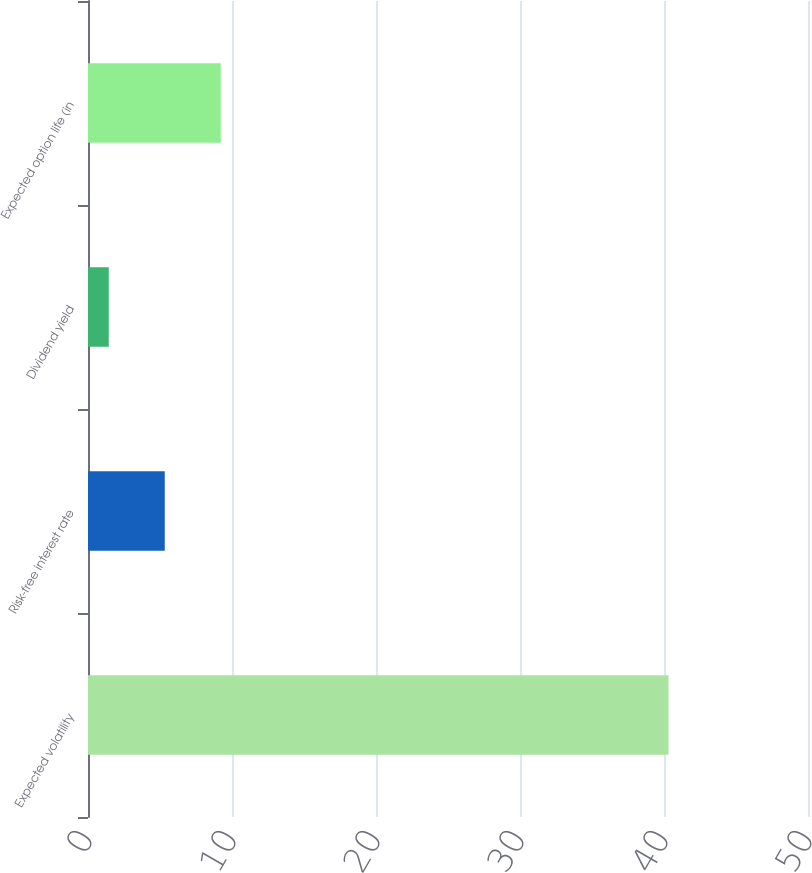Convert chart. <chart><loc_0><loc_0><loc_500><loc_500><bar_chart><fcel>Expected volatility<fcel>Risk-free interest rate<fcel>Dividend yield<fcel>Expected option life (in<nl><fcel>40.31<fcel>5.33<fcel>1.44<fcel>9.22<nl></chart> 